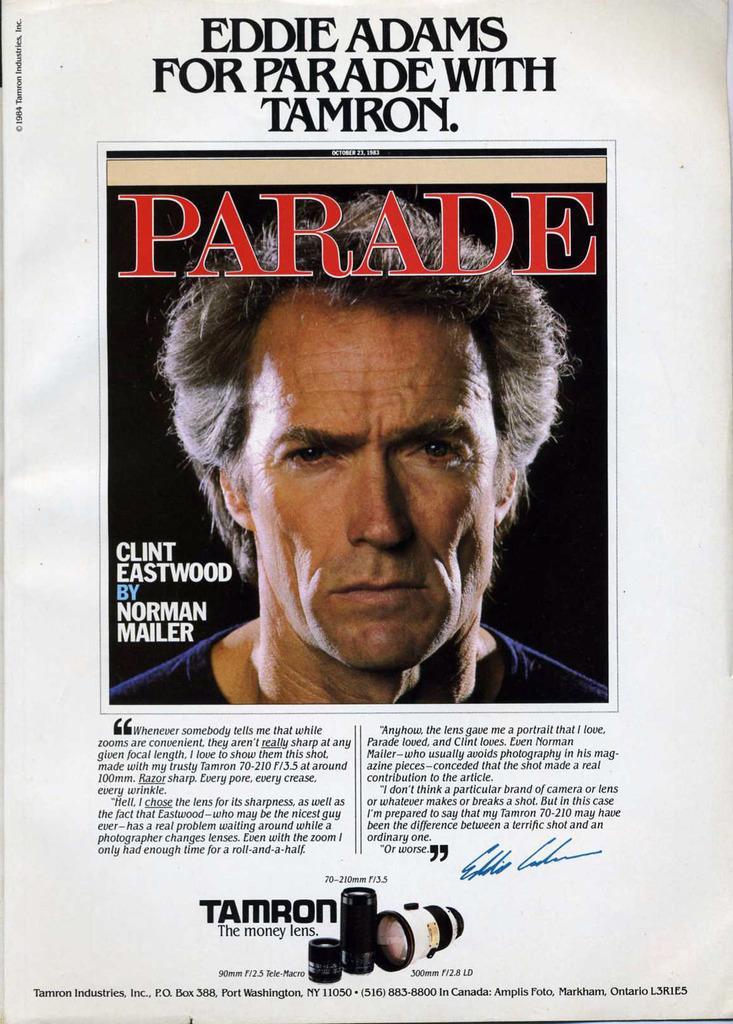In one or two sentences, can you explain what this image depicts? In this picture we can see a paper, in the paper we can find a man and some text. 